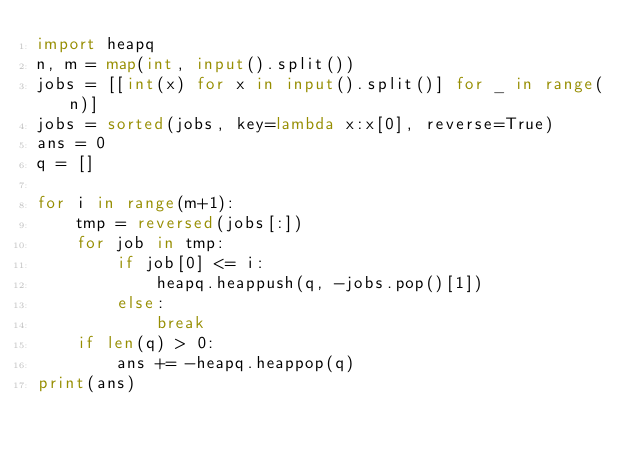<code> <loc_0><loc_0><loc_500><loc_500><_Python_>import heapq
n, m = map(int, input().split())
jobs = [[int(x) for x in input().split()] for _ in range(n)]
jobs = sorted(jobs, key=lambda x:x[0], reverse=True)
ans = 0
q = []

for i in range(m+1):
    tmp = reversed(jobs[:])
    for job in tmp:
        if job[0] <= i:
            heapq.heappush(q, -jobs.pop()[1])
        else:
            break
    if len(q) > 0:
        ans += -heapq.heappop(q)
print(ans)
</code> 